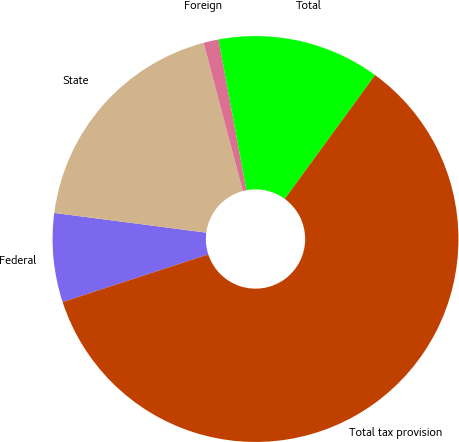<chart> <loc_0><loc_0><loc_500><loc_500><pie_chart><fcel>Federal<fcel>State<fcel>Foreign<fcel>Total<fcel>Total tax provision<nl><fcel>7.08%<fcel>18.83%<fcel>1.2%<fcel>12.95%<fcel>59.94%<nl></chart> 